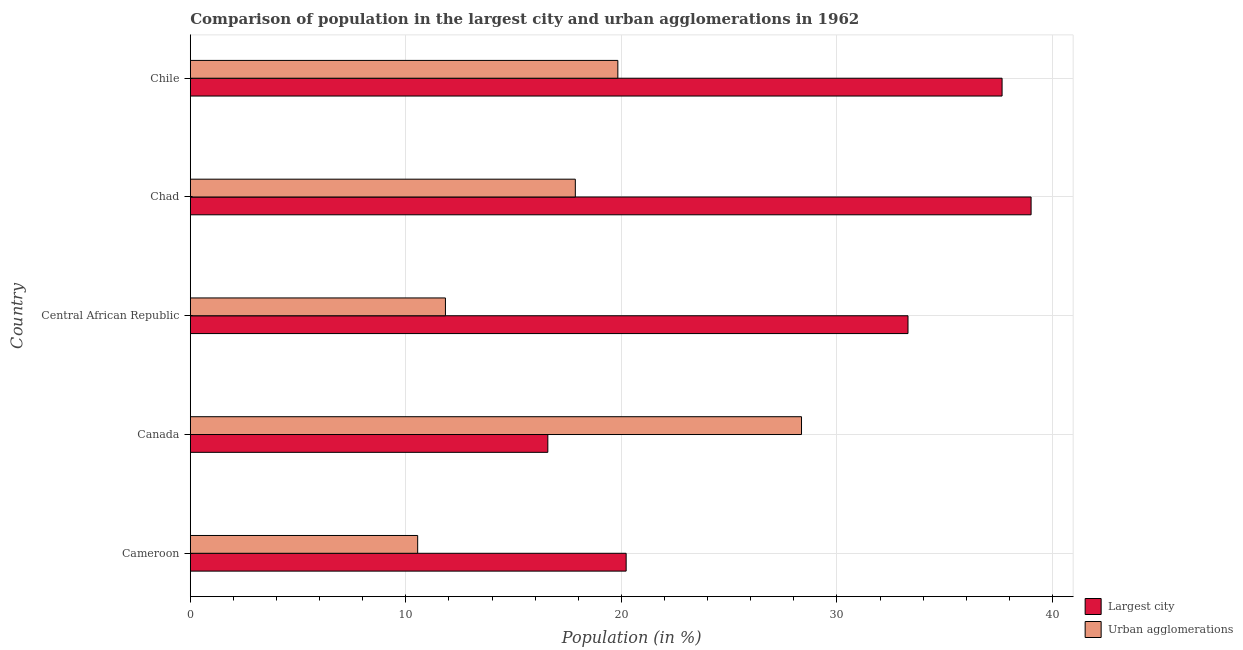How many different coloured bars are there?
Keep it short and to the point. 2. How many bars are there on the 2nd tick from the bottom?
Offer a very short reply. 2. What is the label of the 3rd group of bars from the top?
Provide a short and direct response. Central African Republic. What is the population in urban agglomerations in Central African Republic?
Keep it short and to the point. 11.84. Across all countries, what is the maximum population in the largest city?
Your answer should be very brief. 39.01. Across all countries, what is the minimum population in the largest city?
Keep it short and to the point. 16.59. In which country was the population in urban agglomerations maximum?
Your response must be concise. Canada. In which country was the population in urban agglomerations minimum?
Your response must be concise. Cameroon. What is the total population in the largest city in the graph?
Your answer should be very brief. 146.76. What is the difference between the population in the largest city in Cameroon and that in Chile?
Ensure brevity in your answer.  -17.44. What is the difference between the population in the largest city in Canada and the population in urban agglomerations in Chile?
Your answer should be compact. -3.25. What is the average population in the largest city per country?
Provide a succinct answer. 29.35. What is the difference between the population in the largest city and population in urban agglomerations in Cameroon?
Ensure brevity in your answer.  9.67. In how many countries, is the population in urban agglomerations greater than 10 %?
Your answer should be compact. 5. What is the ratio of the population in urban agglomerations in Cameroon to that in Canada?
Provide a short and direct response. 0.37. Is the population in urban agglomerations in Cameroon less than that in Chad?
Provide a succinct answer. Yes. What is the difference between the highest and the second highest population in the largest city?
Your response must be concise. 1.35. What is the difference between the highest and the lowest population in urban agglomerations?
Your answer should be compact. 17.81. What does the 1st bar from the top in Canada represents?
Provide a succinct answer. Urban agglomerations. What does the 1st bar from the bottom in Cameroon represents?
Your answer should be very brief. Largest city. Are the values on the major ticks of X-axis written in scientific E-notation?
Your answer should be compact. No. How are the legend labels stacked?
Offer a very short reply. Vertical. What is the title of the graph?
Ensure brevity in your answer.  Comparison of population in the largest city and urban agglomerations in 1962. Does "Technicians" appear as one of the legend labels in the graph?
Keep it short and to the point. No. What is the label or title of the X-axis?
Your response must be concise. Population (in %). What is the Population (in %) of Largest city in Cameroon?
Your answer should be compact. 20.22. What is the Population (in %) in Urban agglomerations in Cameroon?
Offer a terse response. 10.55. What is the Population (in %) in Largest city in Canada?
Provide a succinct answer. 16.59. What is the Population (in %) in Urban agglomerations in Canada?
Your response must be concise. 28.35. What is the Population (in %) in Largest city in Central African Republic?
Offer a very short reply. 33.29. What is the Population (in %) in Urban agglomerations in Central African Republic?
Ensure brevity in your answer.  11.84. What is the Population (in %) in Largest city in Chad?
Your response must be concise. 39.01. What is the Population (in %) of Urban agglomerations in Chad?
Give a very brief answer. 17.86. What is the Population (in %) in Largest city in Chile?
Keep it short and to the point. 37.66. What is the Population (in %) in Urban agglomerations in Chile?
Offer a terse response. 19.83. Across all countries, what is the maximum Population (in %) of Largest city?
Provide a short and direct response. 39.01. Across all countries, what is the maximum Population (in %) of Urban agglomerations?
Your answer should be very brief. 28.35. Across all countries, what is the minimum Population (in %) of Largest city?
Offer a terse response. 16.59. Across all countries, what is the minimum Population (in %) in Urban agglomerations?
Provide a short and direct response. 10.55. What is the total Population (in %) of Largest city in the graph?
Ensure brevity in your answer.  146.76. What is the total Population (in %) in Urban agglomerations in the graph?
Offer a terse response. 88.43. What is the difference between the Population (in %) of Largest city in Cameroon and that in Canada?
Make the answer very short. 3.63. What is the difference between the Population (in %) of Urban agglomerations in Cameroon and that in Canada?
Your answer should be compact. -17.81. What is the difference between the Population (in %) in Largest city in Cameroon and that in Central African Republic?
Your response must be concise. -13.07. What is the difference between the Population (in %) in Urban agglomerations in Cameroon and that in Central African Republic?
Make the answer very short. -1.29. What is the difference between the Population (in %) in Largest city in Cameroon and that in Chad?
Provide a succinct answer. -18.79. What is the difference between the Population (in %) in Urban agglomerations in Cameroon and that in Chad?
Offer a very short reply. -7.31. What is the difference between the Population (in %) of Largest city in Cameroon and that in Chile?
Give a very brief answer. -17.44. What is the difference between the Population (in %) of Urban agglomerations in Cameroon and that in Chile?
Your answer should be compact. -9.29. What is the difference between the Population (in %) in Largest city in Canada and that in Central African Republic?
Make the answer very short. -16.71. What is the difference between the Population (in %) in Urban agglomerations in Canada and that in Central African Republic?
Provide a short and direct response. 16.52. What is the difference between the Population (in %) in Largest city in Canada and that in Chad?
Your answer should be compact. -22.42. What is the difference between the Population (in %) of Urban agglomerations in Canada and that in Chad?
Your answer should be compact. 10.49. What is the difference between the Population (in %) of Largest city in Canada and that in Chile?
Keep it short and to the point. -21.07. What is the difference between the Population (in %) in Urban agglomerations in Canada and that in Chile?
Offer a terse response. 8.52. What is the difference between the Population (in %) of Largest city in Central African Republic and that in Chad?
Your answer should be compact. -5.71. What is the difference between the Population (in %) in Urban agglomerations in Central African Republic and that in Chad?
Offer a terse response. -6.03. What is the difference between the Population (in %) of Largest city in Central African Republic and that in Chile?
Make the answer very short. -4.36. What is the difference between the Population (in %) of Urban agglomerations in Central African Republic and that in Chile?
Keep it short and to the point. -8. What is the difference between the Population (in %) in Largest city in Chad and that in Chile?
Your answer should be compact. 1.35. What is the difference between the Population (in %) of Urban agglomerations in Chad and that in Chile?
Ensure brevity in your answer.  -1.97. What is the difference between the Population (in %) in Largest city in Cameroon and the Population (in %) in Urban agglomerations in Canada?
Give a very brief answer. -8.13. What is the difference between the Population (in %) of Largest city in Cameroon and the Population (in %) of Urban agglomerations in Central African Republic?
Your response must be concise. 8.38. What is the difference between the Population (in %) of Largest city in Cameroon and the Population (in %) of Urban agglomerations in Chad?
Ensure brevity in your answer.  2.36. What is the difference between the Population (in %) of Largest city in Cameroon and the Population (in %) of Urban agglomerations in Chile?
Offer a terse response. 0.39. What is the difference between the Population (in %) in Largest city in Canada and the Population (in %) in Urban agglomerations in Central African Republic?
Provide a succinct answer. 4.75. What is the difference between the Population (in %) in Largest city in Canada and the Population (in %) in Urban agglomerations in Chad?
Offer a terse response. -1.28. What is the difference between the Population (in %) in Largest city in Canada and the Population (in %) in Urban agglomerations in Chile?
Your answer should be compact. -3.25. What is the difference between the Population (in %) in Largest city in Central African Republic and the Population (in %) in Urban agglomerations in Chad?
Keep it short and to the point. 15.43. What is the difference between the Population (in %) of Largest city in Central African Republic and the Population (in %) of Urban agglomerations in Chile?
Offer a terse response. 13.46. What is the difference between the Population (in %) of Largest city in Chad and the Population (in %) of Urban agglomerations in Chile?
Give a very brief answer. 19.17. What is the average Population (in %) of Largest city per country?
Make the answer very short. 29.35. What is the average Population (in %) in Urban agglomerations per country?
Keep it short and to the point. 17.69. What is the difference between the Population (in %) in Largest city and Population (in %) in Urban agglomerations in Cameroon?
Your response must be concise. 9.67. What is the difference between the Population (in %) in Largest city and Population (in %) in Urban agglomerations in Canada?
Offer a terse response. -11.77. What is the difference between the Population (in %) in Largest city and Population (in %) in Urban agglomerations in Central African Republic?
Offer a terse response. 21.46. What is the difference between the Population (in %) in Largest city and Population (in %) in Urban agglomerations in Chad?
Offer a very short reply. 21.14. What is the difference between the Population (in %) in Largest city and Population (in %) in Urban agglomerations in Chile?
Your answer should be compact. 17.82. What is the ratio of the Population (in %) of Largest city in Cameroon to that in Canada?
Ensure brevity in your answer.  1.22. What is the ratio of the Population (in %) in Urban agglomerations in Cameroon to that in Canada?
Provide a succinct answer. 0.37. What is the ratio of the Population (in %) in Largest city in Cameroon to that in Central African Republic?
Give a very brief answer. 0.61. What is the ratio of the Population (in %) of Urban agglomerations in Cameroon to that in Central African Republic?
Your answer should be compact. 0.89. What is the ratio of the Population (in %) in Largest city in Cameroon to that in Chad?
Your response must be concise. 0.52. What is the ratio of the Population (in %) in Urban agglomerations in Cameroon to that in Chad?
Keep it short and to the point. 0.59. What is the ratio of the Population (in %) in Largest city in Cameroon to that in Chile?
Your response must be concise. 0.54. What is the ratio of the Population (in %) of Urban agglomerations in Cameroon to that in Chile?
Provide a short and direct response. 0.53. What is the ratio of the Population (in %) in Largest city in Canada to that in Central African Republic?
Your answer should be compact. 0.5. What is the ratio of the Population (in %) in Urban agglomerations in Canada to that in Central African Republic?
Provide a short and direct response. 2.4. What is the ratio of the Population (in %) of Largest city in Canada to that in Chad?
Ensure brevity in your answer.  0.43. What is the ratio of the Population (in %) of Urban agglomerations in Canada to that in Chad?
Make the answer very short. 1.59. What is the ratio of the Population (in %) of Largest city in Canada to that in Chile?
Ensure brevity in your answer.  0.44. What is the ratio of the Population (in %) in Urban agglomerations in Canada to that in Chile?
Offer a very short reply. 1.43. What is the ratio of the Population (in %) of Largest city in Central African Republic to that in Chad?
Your response must be concise. 0.85. What is the ratio of the Population (in %) of Urban agglomerations in Central African Republic to that in Chad?
Keep it short and to the point. 0.66. What is the ratio of the Population (in %) of Largest city in Central African Republic to that in Chile?
Your response must be concise. 0.88. What is the ratio of the Population (in %) in Urban agglomerations in Central African Republic to that in Chile?
Offer a terse response. 0.6. What is the ratio of the Population (in %) of Largest city in Chad to that in Chile?
Keep it short and to the point. 1.04. What is the ratio of the Population (in %) in Urban agglomerations in Chad to that in Chile?
Offer a very short reply. 0.9. What is the difference between the highest and the second highest Population (in %) of Largest city?
Your answer should be compact. 1.35. What is the difference between the highest and the second highest Population (in %) of Urban agglomerations?
Give a very brief answer. 8.52. What is the difference between the highest and the lowest Population (in %) of Largest city?
Provide a short and direct response. 22.42. What is the difference between the highest and the lowest Population (in %) of Urban agglomerations?
Your answer should be very brief. 17.81. 